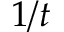<formula> <loc_0><loc_0><loc_500><loc_500>1 / t</formula> 